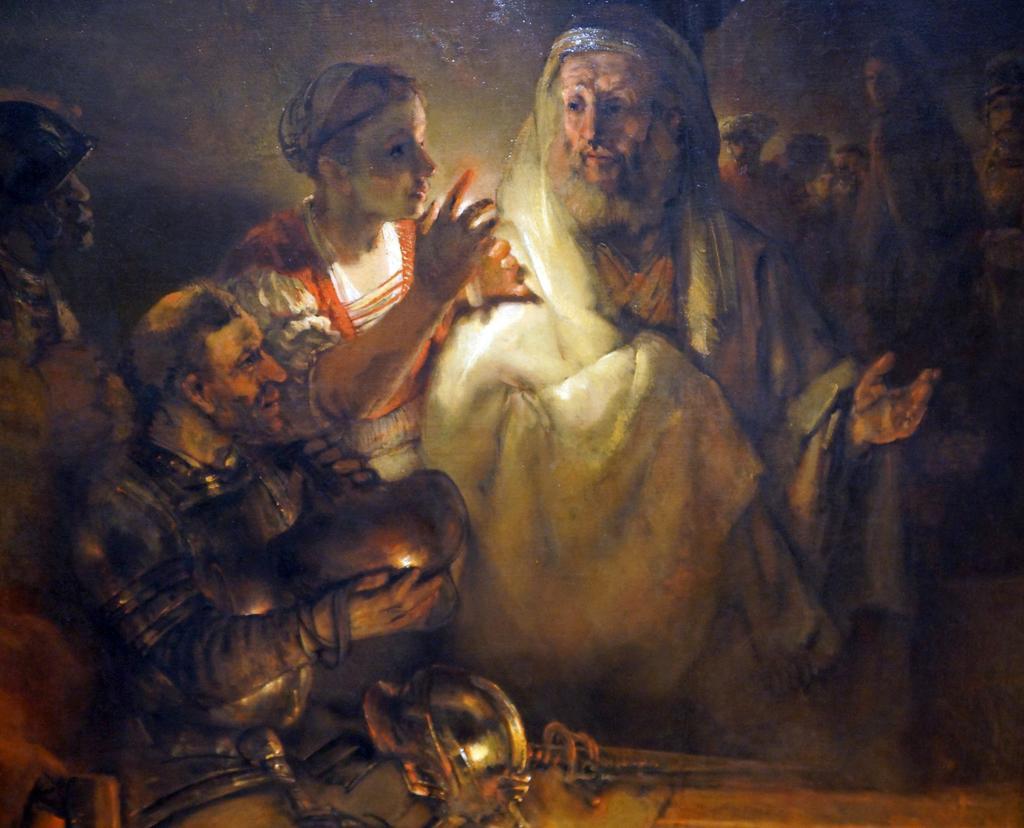Please provide a concise description of this image. This is the picture of the painting. In this picture, we see three men and a woman. The man in front of the picture is holding an object in his hands. On the right side, we see the people are standing. In the background, it is grey in color. This picture might be clicked in the dark. 